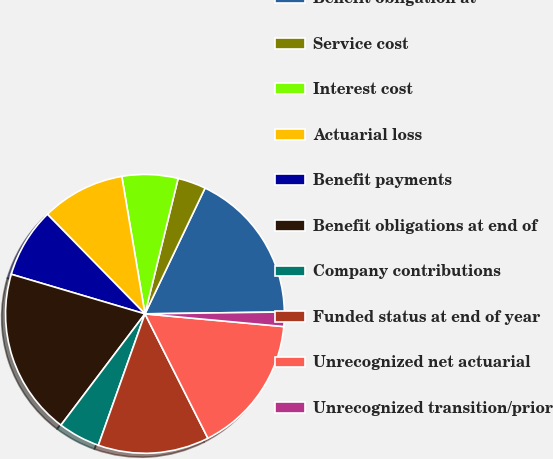Convert chart. <chart><loc_0><loc_0><loc_500><loc_500><pie_chart><fcel>Benefit obligation at<fcel>Service cost<fcel>Interest cost<fcel>Actuarial loss<fcel>Benefit payments<fcel>Benefit obligations at end of<fcel>Company contributions<fcel>Funded status at end of year<fcel>Unrecognized net actuarial<fcel>Unrecognized transition/prior<nl><fcel>17.69%<fcel>3.27%<fcel>6.48%<fcel>9.68%<fcel>8.08%<fcel>19.29%<fcel>4.87%<fcel>12.88%<fcel>16.09%<fcel>1.67%<nl></chart> 